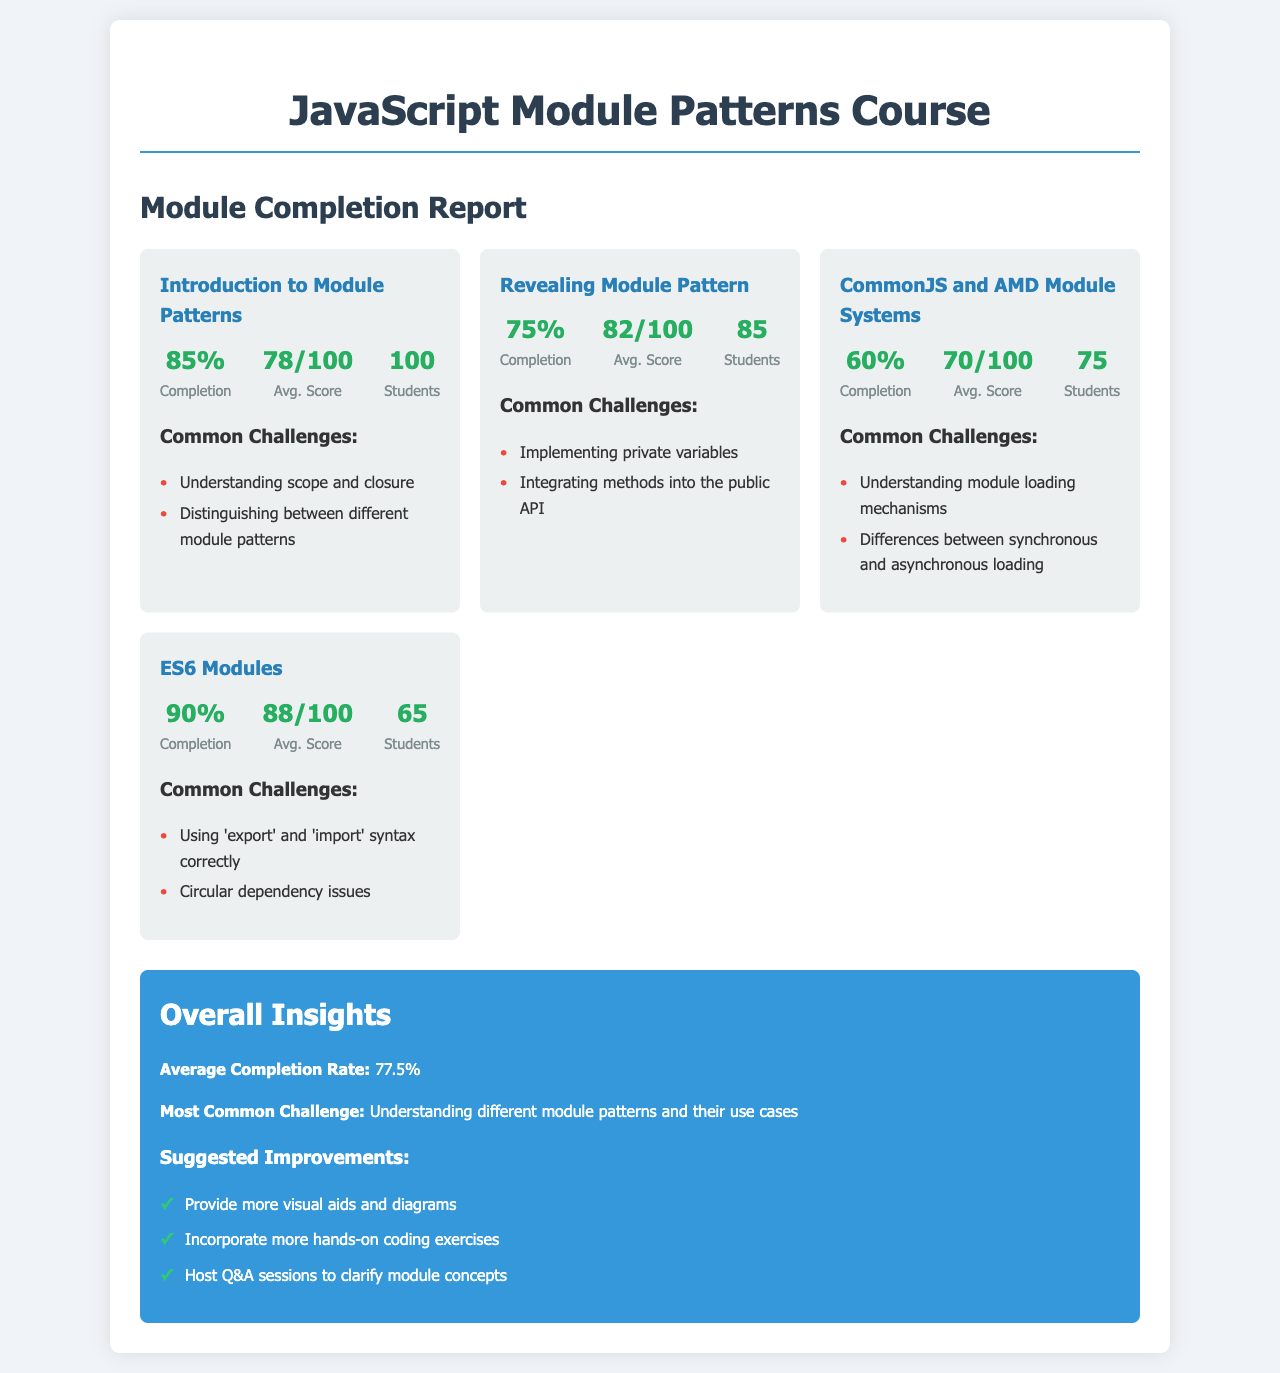What is the completion rate for the "Revealing Module Pattern"? The completion rate for the "Revealing Module Pattern" is specifically provided in the document.
Answer: 75% How many students completed the "Introduction to Module Patterns"? The number of students enrolled in the "Introduction to Module Patterns" is noted in the report.
Answer: 100 What was the average score for ES6 Modules? The average score for ES6 Modules can be found within the module statistics.
Answer: 88/100 What is the overall average completion rate? The overall average completion rate is calculated from all module completion rates given in the document.
Answer: 77.5% What is the most common challenge faced by novices? The document provides insights into the most common challenge experienced by students across modules.
Answer: Understanding different module patterns and their use cases Which module had the highest completion rate? By comparing the completion rates of all modules listed, we can determine the one that is highest.
Answer: ES6 Modules What are suggested improvements for the course? Suggestions for improving the course are clearly listed in the "Overall Insights" section of the document.
Answer: Provide more visual aids and diagrams How many students completed the CommonJS and AMD Module Systems module? The number of students who completed the CommonJS and AMD Module Systems is detailed in the report.
Answer: 75 What challenge is associated with the Revealing Module Pattern? The challenges faced in the Revealing Module Pattern are explicitly stated in the module card.
Answer: Implementing private variables 